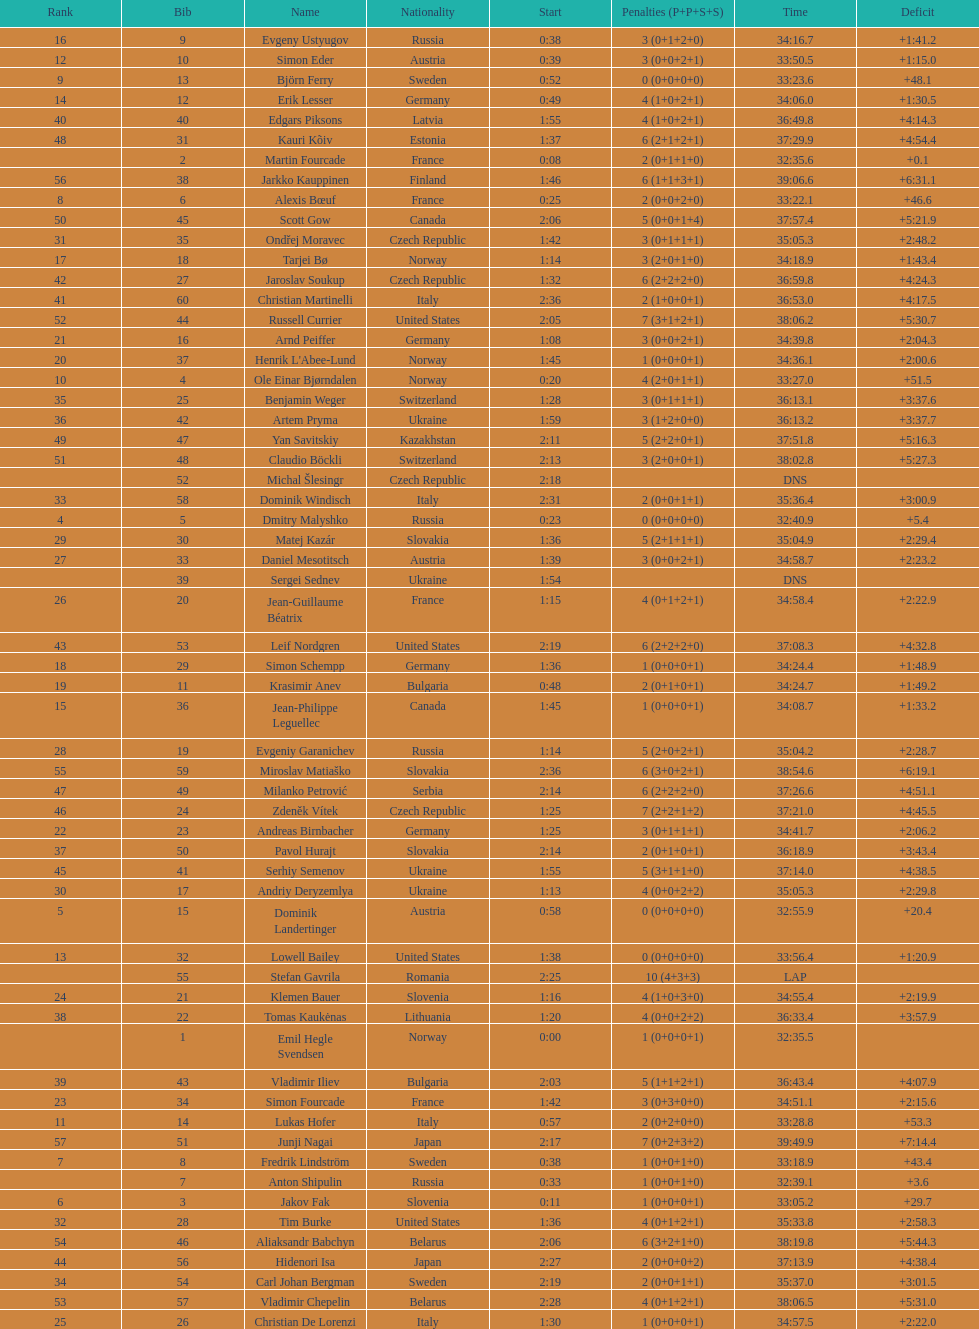Who is the top ranked runner of sweden? Fredrik Lindström. 